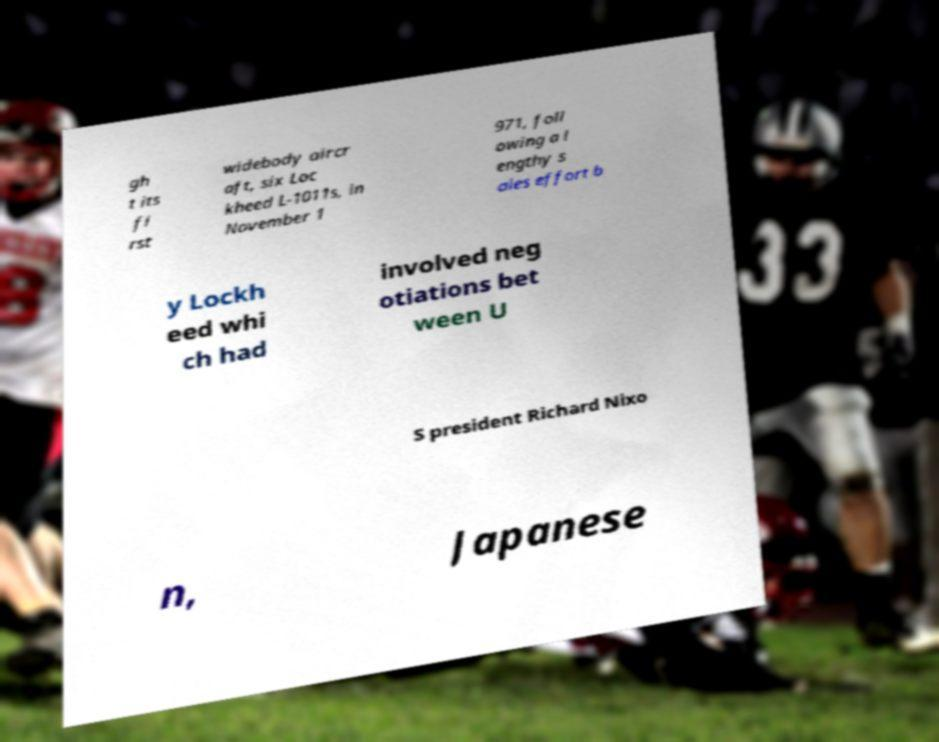Please identify and transcribe the text found in this image. gh t its fi rst widebody aircr aft, six Loc kheed L-1011s, in November 1 971, foll owing a l engthy s ales effort b y Lockh eed whi ch had involved neg otiations bet ween U S president Richard Nixo n, Japanese 